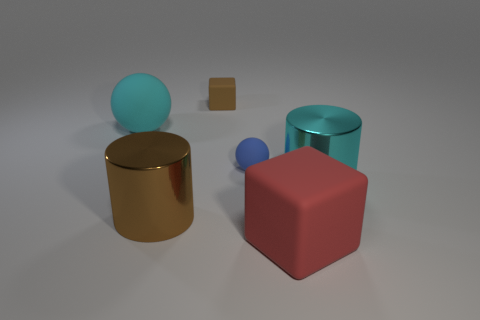Add 3 yellow metal balls. How many objects exist? 9 Subtract all blocks. How many objects are left? 4 Add 3 cyan rubber balls. How many cyan rubber balls are left? 4 Add 2 big blue rubber cylinders. How many big blue rubber cylinders exist? 2 Subtract 0 green cylinders. How many objects are left? 6 Subtract all tiny brown blocks. Subtract all large metal cylinders. How many objects are left? 3 